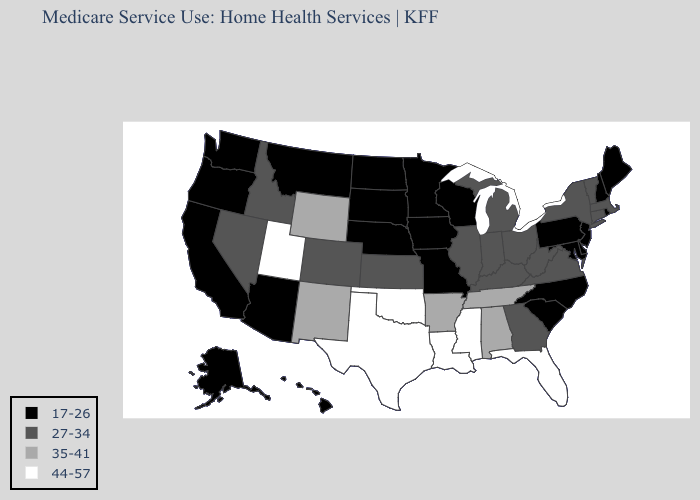Name the states that have a value in the range 44-57?
Write a very short answer. Florida, Louisiana, Mississippi, Oklahoma, Texas, Utah. Name the states that have a value in the range 35-41?
Quick response, please. Alabama, Arkansas, New Mexico, Tennessee, Wyoming. Name the states that have a value in the range 17-26?
Write a very short answer. Alaska, Arizona, California, Delaware, Hawaii, Iowa, Maine, Maryland, Minnesota, Missouri, Montana, Nebraska, New Hampshire, New Jersey, North Carolina, North Dakota, Oregon, Pennsylvania, Rhode Island, South Carolina, South Dakota, Washington, Wisconsin. Does Florida have a lower value than Washington?
Give a very brief answer. No. Does the map have missing data?
Be succinct. No. What is the value of Missouri?
Write a very short answer. 17-26. Name the states that have a value in the range 35-41?
Be succinct. Alabama, Arkansas, New Mexico, Tennessee, Wyoming. What is the value of Kansas?
Concise answer only. 27-34. What is the value of Kentucky?
Quick response, please. 27-34. What is the value of Oregon?
Give a very brief answer. 17-26. What is the lowest value in the USA?
Be succinct. 17-26. Does Alaska have the highest value in the USA?
Quick response, please. No. Name the states that have a value in the range 27-34?
Answer briefly. Colorado, Connecticut, Georgia, Idaho, Illinois, Indiana, Kansas, Kentucky, Massachusetts, Michigan, Nevada, New York, Ohio, Vermont, Virginia, West Virginia. Does the first symbol in the legend represent the smallest category?
Short answer required. Yes. Does Missouri have the highest value in the MidWest?
Short answer required. No. 